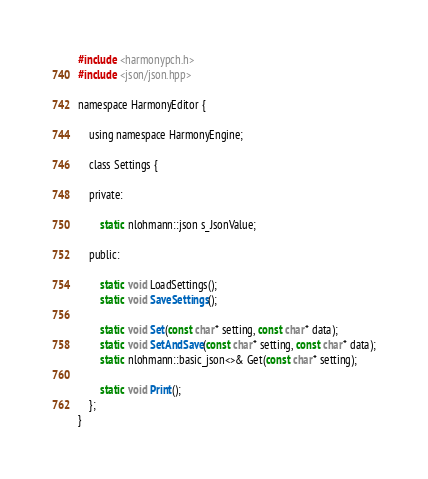Convert code to text. <code><loc_0><loc_0><loc_500><loc_500><_C_>#include <harmonypch.h>
#include <json/json.hpp>

namespace HarmonyEditor {

    using namespace HarmonyEngine;

    class Settings {

    private:

        static nlohmann::json s_JsonValue;

    public:

        static void LoadSettings();
        static void SaveSettings();

        static void Set(const char* setting, const char* data);
        static void SetAndSave(const char* setting, const char* data);
        static nlohmann::basic_json<>& Get(const char* setting);

        static void Print();
    };
}</code> 